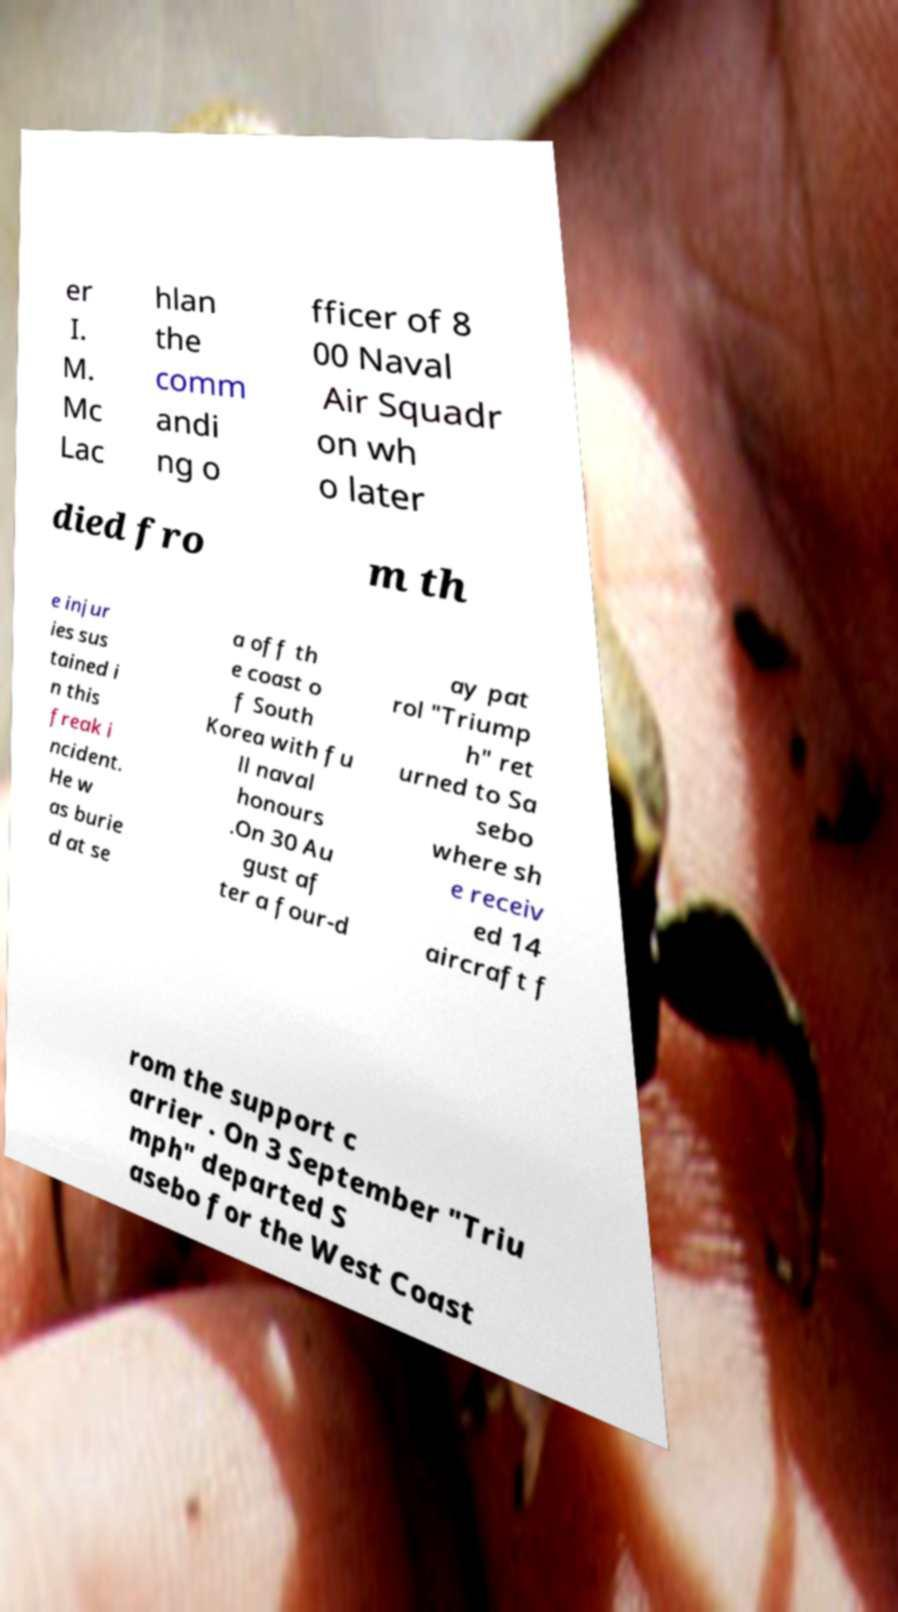Can you read and provide the text displayed in the image?This photo seems to have some interesting text. Can you extract and type it out for me? er I. M. Mc Lac hlan the comm andi ng o fficer of 8 00 Naval Air Squadr on wh o later died fro m th e injur ies sus tained i n this freak i ncident. He w as burie d at se a off th e coast o f South Korea with fu ll naval honours .On 30 Au gust af ter a four-d ay pat rol "Triump h" ret urned to Sa sebo where sh e receiv ed 14 aircraft f rom the support c arrier . On 3 September "Triu mph" departed S asebo for the West Coast 